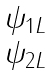Convert formula to latex. <formula><loc_0><loc_0><loc_500><loc_500>\begin{matrix} \psi _ { 1 L } \\ \psi _ { 2 L } \end{matrix}</formula> 